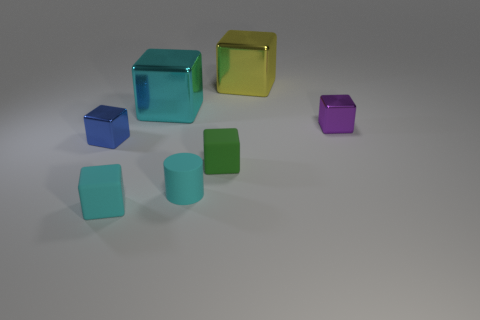Are there any indications about the size of the objects or the scale of the scene? There are no clear indications of scale, such as a familiar object or pattern for reference. Without these, it's not possible to determine the actual size of the objects or the overall scale of the scene from the image alone. 